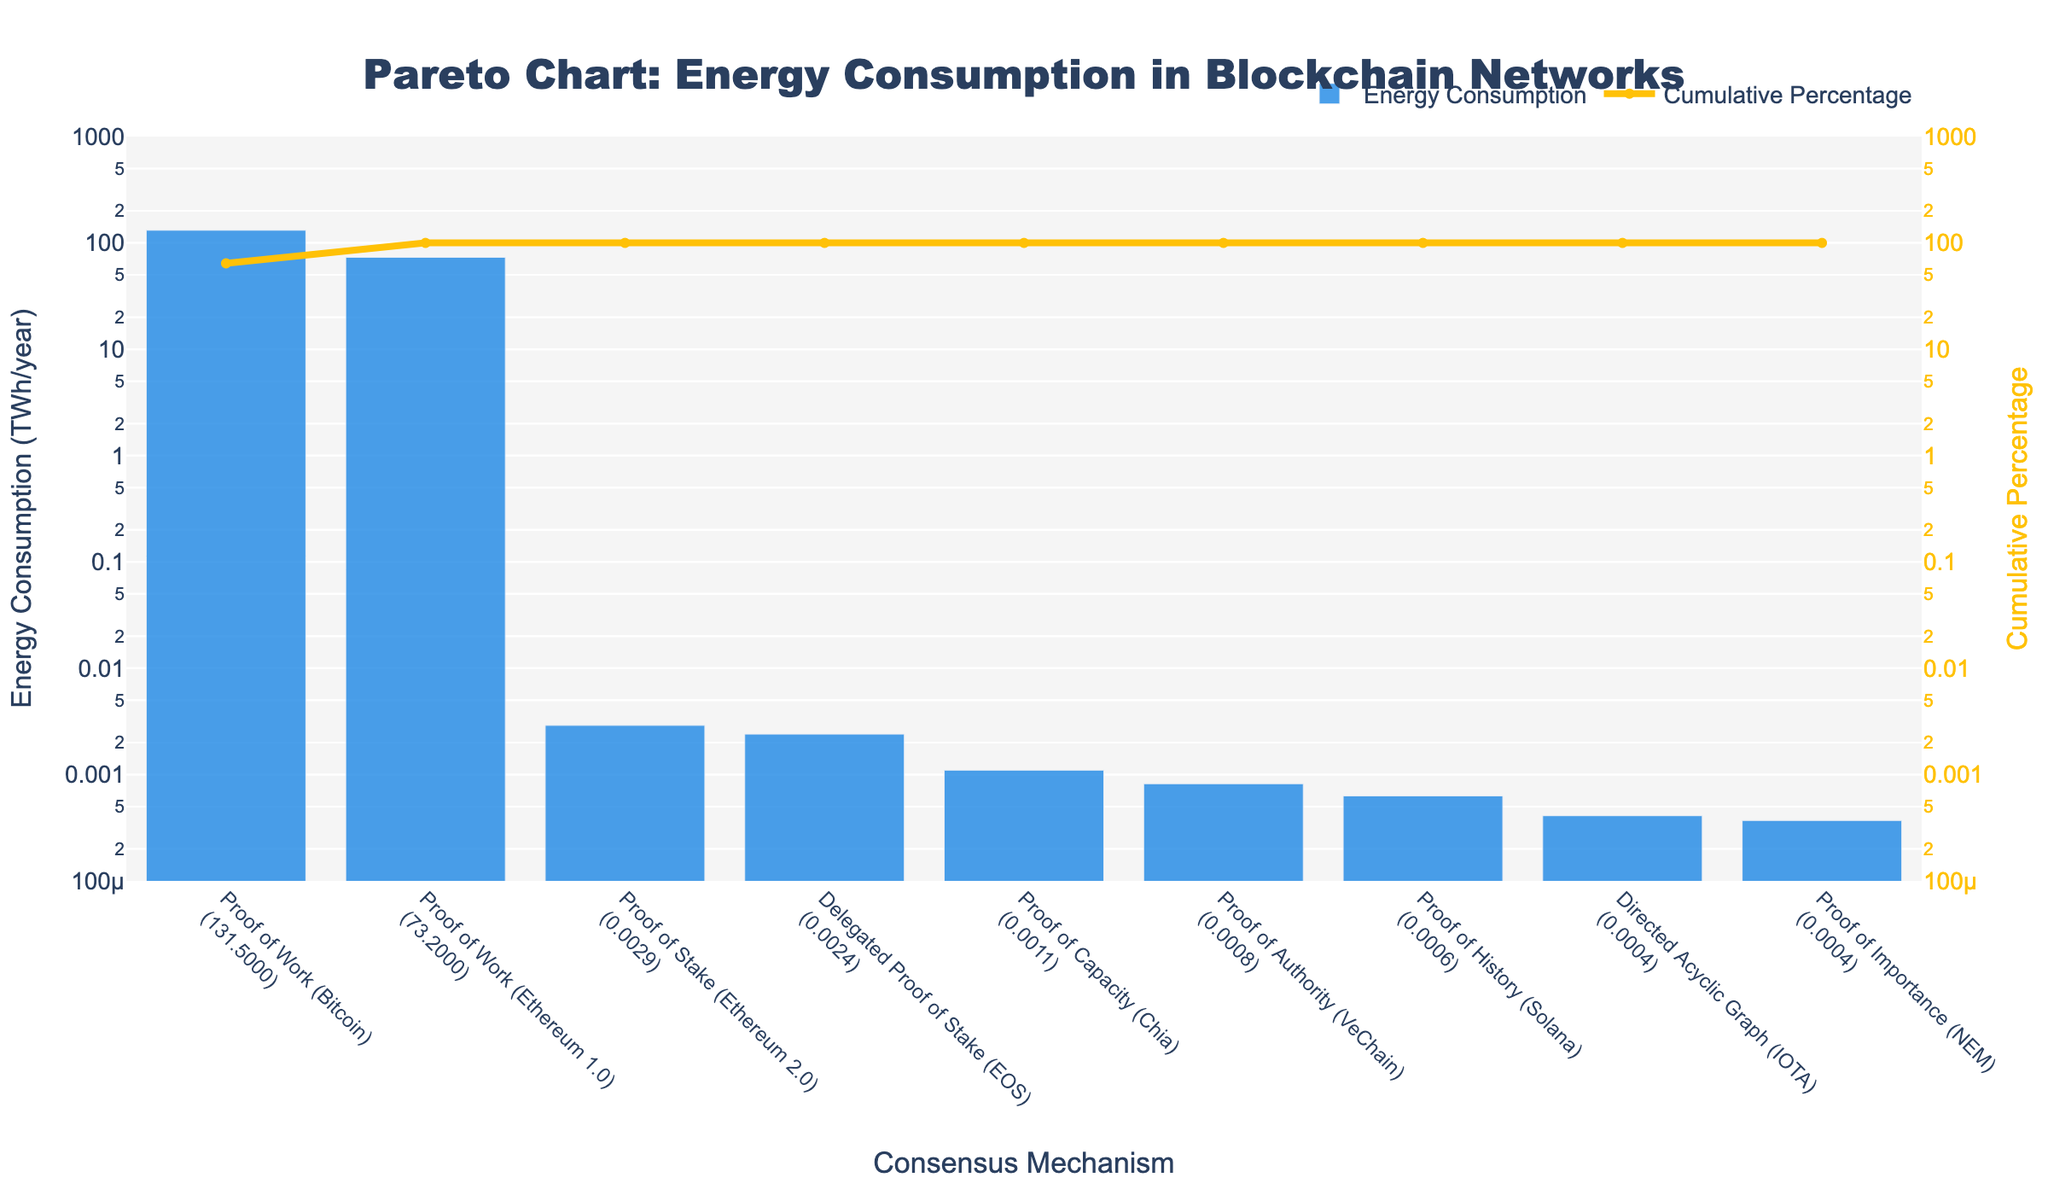What is the title of the chart? The title of the chart is generally located at the top of the figure and summarizes the content. The title "Pareto Chart: Energy Consumption in Blockchain Networks" clearly indicates that the chart depicts the energy consumption of different blockchain networks using various consensus mechanisms.
Answer: Pareto Chart: Energy Consumption in Blockchain Networks Which consensus mechanism has the highest energy consumption? To find the consensus mechanism with the highest energy consumption, look at the tallest bar in the figure. Proof of Work (Bitcoin) has the tallest bar, indicating it has the highest energy consumption.
Answer: Proof of Work (Bitcoin) What is the cumulative percentage of energy consumption when adding Proof of Work (Bitcoin) and Proof of Work (Ethereum 1.0)? Locate the cumulative percentage values for both Proof of Work (Bitcoin) and Proof of Work (Ethereum 1.0). Add these two percentages together. For Bitcoin, it is the first point on the line, and for Ethereum 1.0, it is the second. These values are approximately 58% and 89%, respectively. So, the sum is 58% + 31% = 89%.
Answer: 89% How do Proof of Stake (Ethereum 2.0) and Directed Acyclic Graph (IOTA) compare in terms of energy consumption? Find the bars corresponding to Proof of Stake (Ethereum 2.0) and Directed Acyclic Graph (IOTA). By comparing the heights, we see that Ethereum 2.0 consumes more energy than IOTA.
Answer: Proof of Stake (Ethereum 2.0) consumes more What percentage of the total energy consumption is contributed by Proof of Work (Bitcoin)? The cumulative percentage value for Proof of Work (Bitcoin) is provided at the first point of the line plot. This value is around 58%.
Answer: 58% Which consensus mechanisms contribute less than 0.001 TWh/year? Look at the bars with values less than 0.001 TWh/year. Proof of History (Solana), Directed Acyclic Graph (IOTA), and Proof of Importance (NEM) all satisfy this condition.
Answer: Solana, IOTA, NEM What is the total energy consumption of the mechanisms other than Proof of Work (Bitcoin) and Proof of Work (Ethereum 1.0)? Subtract the sum of the energy consumption values for Proof of Work (Bitcoin) and Proof of Work (Ethereum 1.0) from the total. The total is 204.4 TWh/year. The sum of Bitcoin and Ethereum 1.0 is 204.7 TWh/year giving an approximate total consumption for other mechanisms as 204.7 - 204.4 = 0.3 TWh/year.
Answer: 0.3 TWh/year What is the color of the bars representing energy consumption? The bars are typically one uniform color in the figure. In this case, the bars are colored blue.
Answer: Blue What is the energy consumption of Delegated Proof of Stake (EOS) relative to Proof of Stake (Ethereum 2.0)? Compare the heights of the bars for Delegated Proof of Stake (EOS) and Proof of Stake (Ethereum 2.0). EOS has a slightly lower height than Ethereum 2.0.
Answer: EOS is lower than Ethereum 2.0 Which three consensus mechanisms have the lowest energy consumption? Identify the last three bars with the smallest heights on the chart. These are Proof of Importance (NEM), Directed Acyclic Graph (IOTA), and Proof of History (Solana).
Answer: NEM, IOTA, Solana 